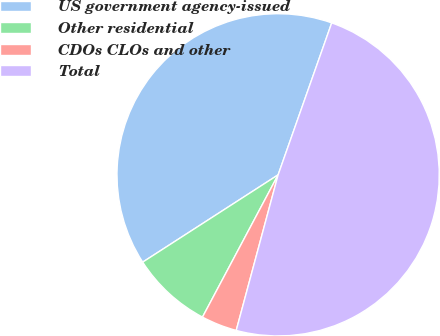Convert chart. <chart><loc_0><loc_0><loc_500><loc_500><pie_chart><fcel>US government agency-issued<fcel>Other residential<fcel>CDOs CLOs and other<fcel>Total<nl><fcel>39.51%<fcel>8.11%<fcel>3.59%<fcel>48.79%<nl></chart> 